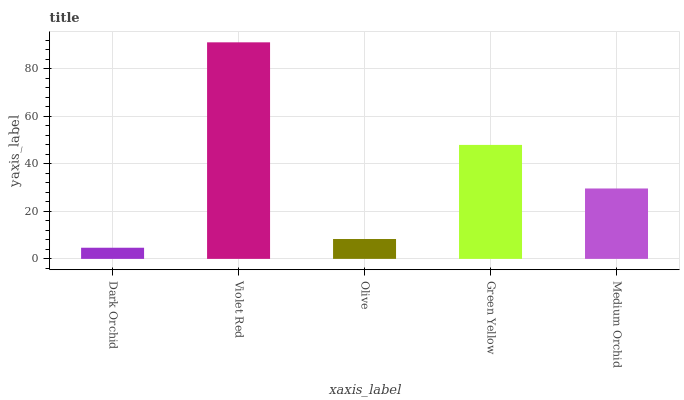Is Dark Orchid the minimum?
Answer yes or no. Yes. Is Violet Red the maximum?
Answer yes or no. Yes. Is Olive the minimum?
Answer yes or no. No. Is Olive the maximum?
Answer yes or no. No. Is Violet Red greater than Olive?
Answer yes or no. Yes. Is Olive less than Violet Red?
Answer yes or no. Yes. Is Olive greater than Violet Red?
Answer yes or no. No. Is Violet Red less than Olive?
Answer yes or no. No. Is Medium Orchid the high median?
Answer yes or no. Yes. Is Medium Orchid the low median?
Answer yes or no. Yes. Is Green Yellow the high median?
Answer yes or no. No. Is Violet Red the low median?
Answer yes or no. No. 